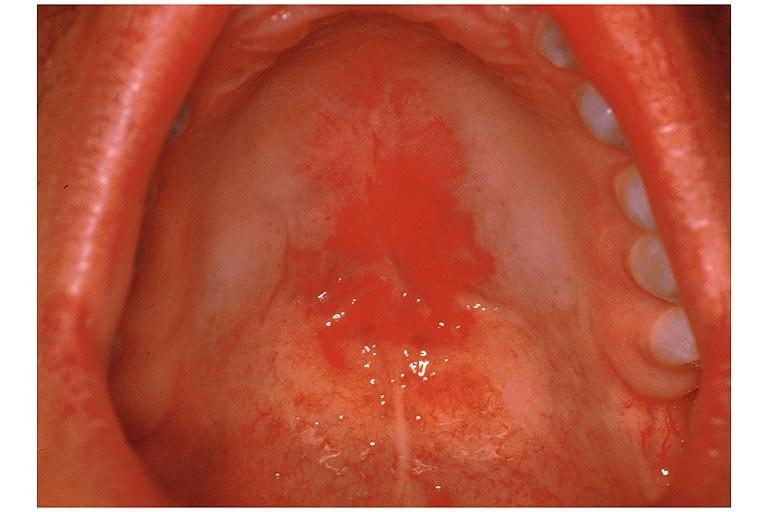what is present?
Answer the question using a single word or phrase. Oral 